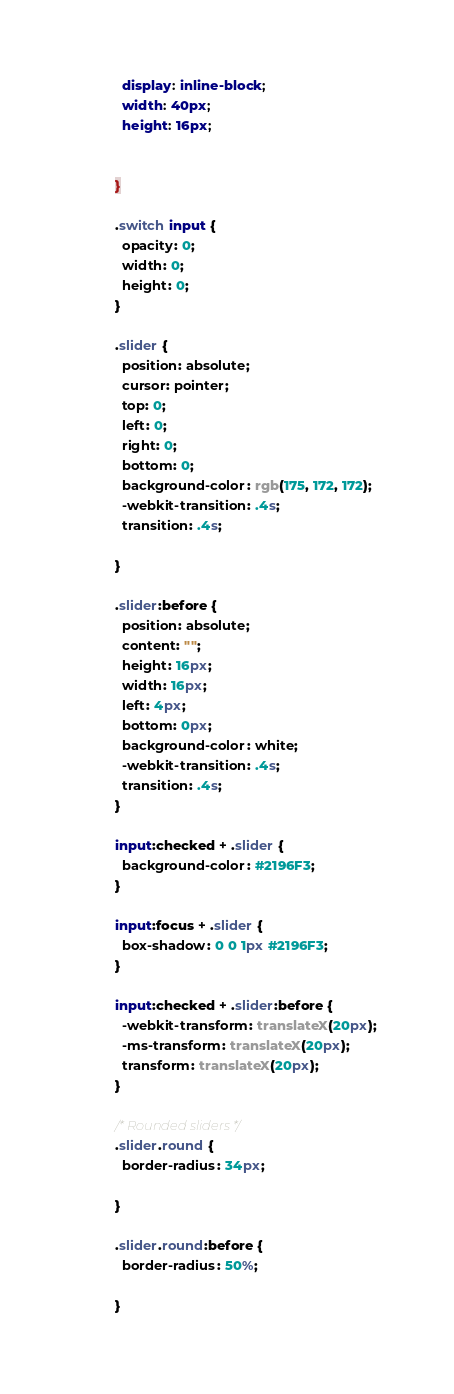<code> <loc_0><loc_0><loc_500><loc_500><_CSS_>            display: inline-block;
            width: 40px;
            height: 16px;
            
           
          }
          
          .switch input { 
            opacity: 0;
            width: 0;
            height: 0;
          }
          
          .slider {
            position: absolute;
            cursor: pointer;
            top: 0;
            left: 0;
            right: 0;
            bottom: 0;
            background-color: rgb(175, 172, 172);
            -webkit-transition: .4s;
            transition: .4s;
          
          }
          
          .slider:before {
            position: absolute;
            content: "";
            height: 16px;
            width: 16px;
            left: 4px;
            bottom: 0px;
            background-color: white;
            -webkit-transition: .4s;
            transition: .4s;
          }
          
          input:checked + .slider {
            background-color: #2196F3;
          }
          
          input:focus + .slider {
            box-shadow: 0 0 1px #2196F3;
          }
          
          input:checked + .slider:before {
            -webkit-transform: translateX(20px);
            -ms-transform: translateX(20px);
            transform: translateX(20px);
          }
          
          /* Rounded sliders */
          .slider.round {
            border-radius: 34px;
            
          }
          
          .slider.round:before {
            border-radius: 50%;
            
          }</code> 